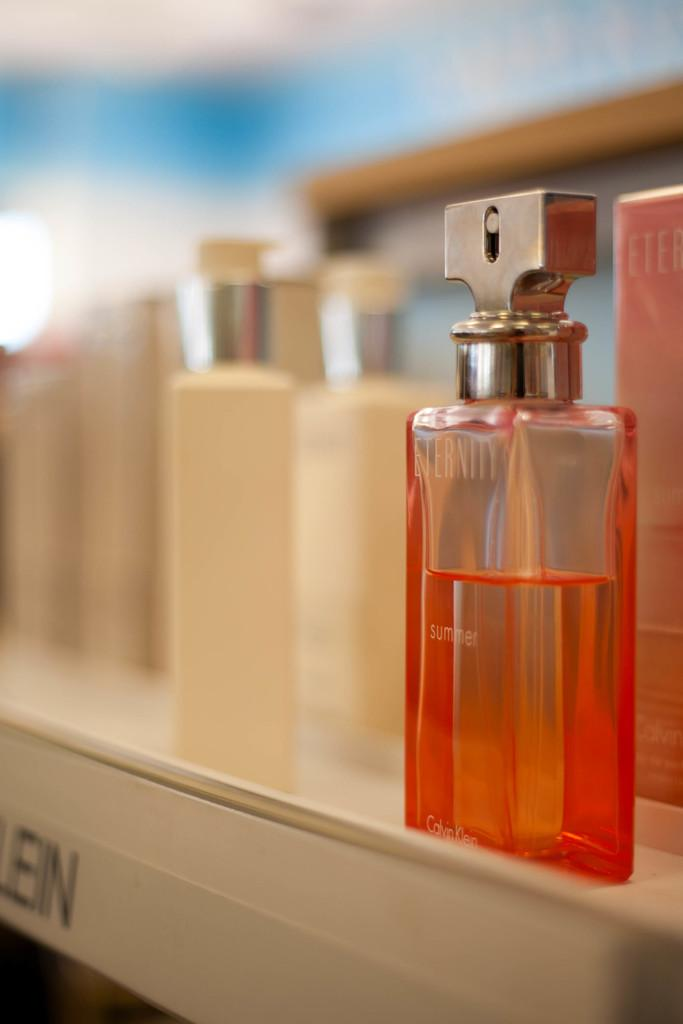<image>
Write a terse but informative summary of the picture. eternity perfum sits on a rack it looks half used 